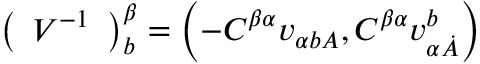Convert formula to latex. <formula><loc_0><loc_0><loc_500><loc_500>\left ( \begin{array} { l } { { V ^ { - { 1 } } } } \end{array} \right ) _ { b } ^ { \beta } = \left ( - C ^ { { \beta } { \alpha } } v _ { { \alpha } { { b } A } } , C ^ { { \beta } { \alpha } } v _ { { \alpha } { \dot { A } } } ^ { b } \right )</formula> 